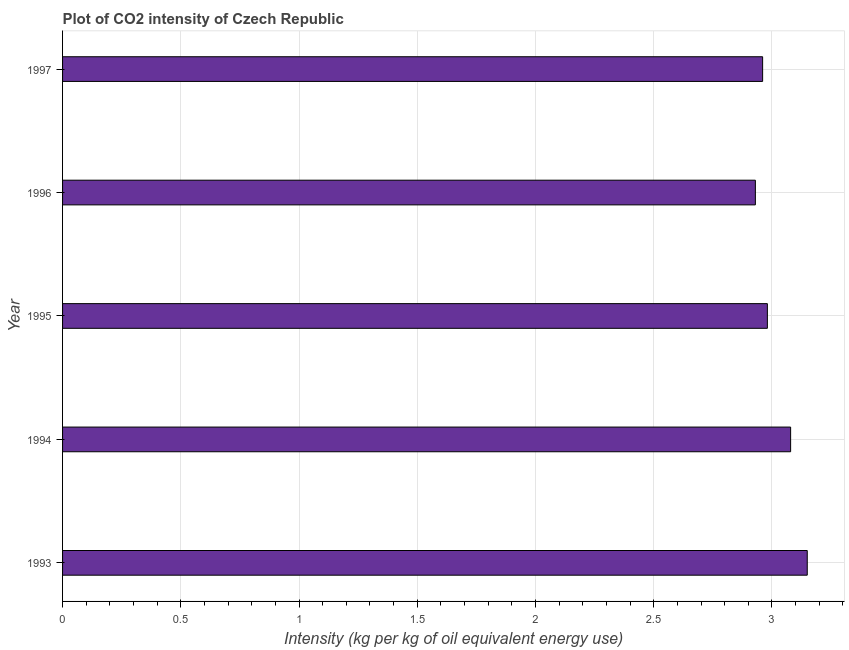Does the graph contain any zero values?
Provide a short and direct response. No. What is the title of the graph?
Ensure brevity in your answer.  Plot of CO2 intensity of Czech Republic. What is the label or title of the X-axis?
Keep it short and to the point. Intensity (kg per kg of oil equivalent energy use). What is the co2 intensity in 1994?
Give a very brief answer. 3.08. Across all years, what is the maximum co2 intensity?
Keep it short and to the point. 3.15. Across all years, what is the minimum co2 intensity?
Give a very brief answer. 2.93. In which year was the co2 intensity minimum?
Keep it short and to the point. 1996. What is the sum of the co2 intensity?
Make the answer very short. 15.1. What is the difference between the co2 intensity in 1993 and 1994?
Offer a very short reply. 0.07. What is the average co2 intensity per year?
Ensure brevity in your answer.  3.02. What is the median co2 intensity?
Provide a short and direct response. 2.98. Do a majority of the years between 1995 and 1994 (inclusive) have co2 intensity greater than 2.5 kg?
Your answer should be compact. No. Is the co2 intensity in 1994 less than that in 1995?
Provide a succinct answer. No. Is the difference between the co2 intensity in 1995 and 1996 greater than the difference between any two years?
Provide a succinct answer. No. What is the difference between the highest and the second highest co2 intensity?
Offer a very short reply. 0.07. What is the difference between the highest and the lowest co2 intensity?
Your answer should be very brief. 0.22. In how many years, is the co2 intensity greater than the average co2 intensity taken over all years?
Offer a very short reply. 2. How many bars are there?
Provide a short and direct response. 5. Are all the bars in the graph horizontal?
Give a very brief answer. Yes. How many years are there in the graph?
Keep it short and to the point. 5. What is the difference between two consecutive major ticks on the X-axis?
Your response must be concise. 0.5. What is the Intensity (kg per kg of oil equivalent energy use) in 1993?
Provide a short and direct response. 3.15. What is the Intensity (kg per kg of oil equivalent energy use) in 1994?
Your response must be concise. 3.08. What is the Intensity (kg per kg of oil equivalent energy use) of 1995?
Offer a terse response. 2.98. What is the Intensity (kg per kg of oil equivalent energy use) in 1996?
Make the answer very short. 2.93. What is the Intensity (kg per kg of oil equivalent energy use) of 1997?
Give a very brief answer. 2.96. What is the difference between the Intensity (kg per kg of oil equivalent energy use) in 1993 and 1994?
Your answer should be compact. 0.07. What is the difference between the Intensity (kg per kg of oil equivalent energy use) in 1993 and 1995?
Give a very brief answer. 0.17. What is the difference between the Intensity (kg per kg of oil equivalent energy use) in 1993 and 1996?
Provide a short and direct response. 0.22. What is the difference between the Intensity (kg per kg of oil equivalent energy use) in 1993 and 1997?
Give a very brief answer. 0.19. What is the difference between the Intensity (kg per kg of oil equivalent energy use) in 1994 and 1995?
Ensure brevity in your answer.  0.1. What is the difference between the Intensity (kg per kg of oil equivalent energy use) in 1994 and 1996?
Give a very brief answer. 0.15. What is the difference between the Intensity (kg per kg of oil equivalent energy use) in 1994 and 1997?
Your response must be concise. 0.12. What is the difference between the Intensity (kg per kg of oil equivalent energy use) in 1995 and 1996?
Your response must be concise. 0.05. What is the difference between the Intensity (kg per kg of oil equivalent energy use) in 1995 and 1997?
Keep it short and to the point. 0.02. What is the difference between the Intensity (kg per kg of oil equivalent energy use) in 1996 and 1997?
Your answer should be very brief. -0.03. What is the ratio of the Intensity (kg per kg of oil equivalent energy use) in 1993 to that in 1995?
Your response must be concise. 1.06. What is the ratio of the Intensity (kg per kg of oil equivalent energy use) in 1993 to that in 1996?
Provide a succinct answer. 1.07. What is the ratio of the Intensity (kg per kg of oil equivalent energy use) in 1993 to that in 1997?
Your answer should be very brief. 1.06. What is the ratio of the Intensity (kg per kg of oil equivalent energy use) in 1994 to that in 1995?
Provide a succinct answer. 1.03. What is the ratio of the Intensity (kg per kg of oil equivalent energy use) in 1994 to that in 1996?
Your answer should be compact. 1.05. What is the ratio of the Intensity (kg per kg of oil equivalent energy use) in 1994 to that in 1997?
Your response must be concise. 1.04. What is the ratio of the Intensity (kg per kg of oil equivalent energy use) in 1995 to that in 1996?
Keep it short and to the point. 1.02. 